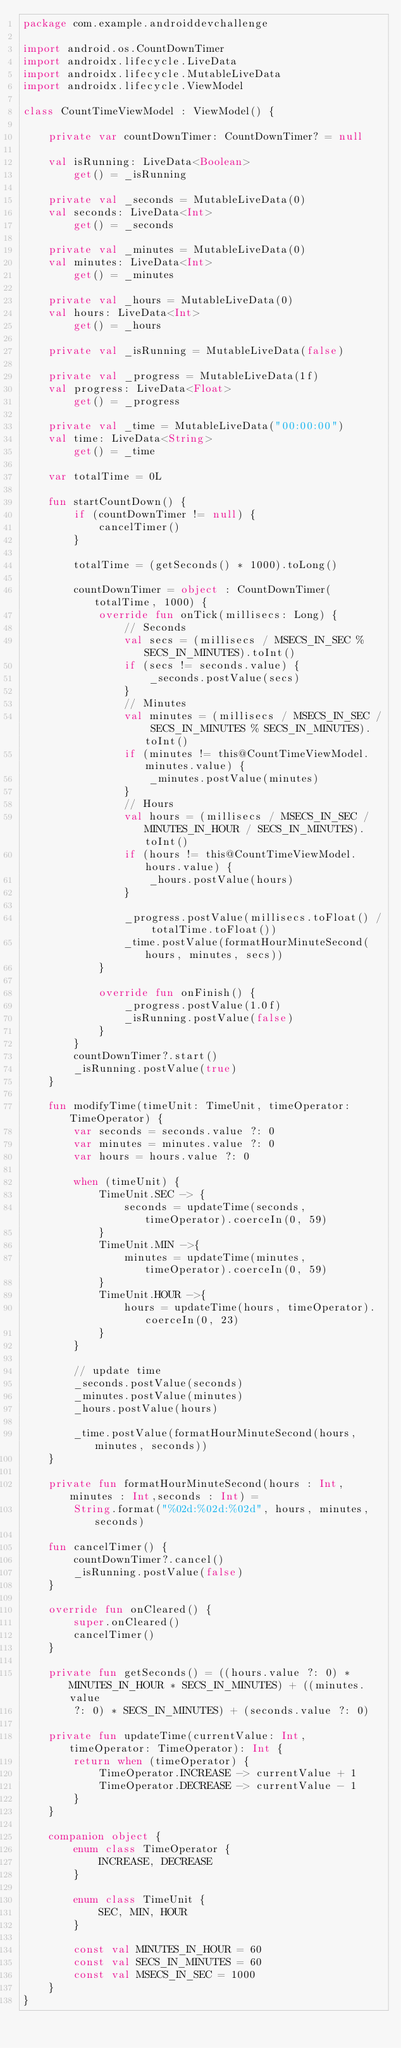Convert code to text. <code><loc_0><loc_0><loc_500><loc_500><_Kotlin_>package com.example.androiddevchallenge

import android.os.CountDownTimer
import androidx.lifecycle.LiveData
import androidx.lifecycle.MutableLiveData
import androidx.lifecycle.ViewModel

class CountTimeViewModel : ViewModel() {

    private var countDownTimer: CountDownTimer? = null

    val isRunning: LiveData<Boolean>
        get() = _isRunning

    private val _seconds = MutableLiveData(0)
    val seconds: LiveData<Int>
        get() = _seconds

    private val _minutes = MutableLiveData(0)
    val minutes: LiveData<Int>
        get() = _minutes

    private val _hours = MutableLiveData(0)
    val hours: LiveData<Int>
        get() = _hours

    private val _isRunning = MutableLiveData(false)

    private val _progress = MutableLiveData(1f)
    val progress: LiveData<Float>
        get() = _progress

    private val _time = MutableLiveData("00:00:00")
    val time: LiveData<String>
        get() = _time

    var totalTime = 0L

    fun startCountDown() {
        if (countDownTimer != null) {
            cancelTimer()
        }

        totalTime = (getSeconds() * 1000).toLong()

        countDownTimer = object : CountDownTimer(totalTime, 1000) {
            override fun onTick(millisecs: Long) {
                // Seconds
                val secs = (millisecs / MSECS_IN_SEC % SECS_IN_MINUTES).toInt()
                if (secs != seconds.value) {
                    _seconds.postValue(secs)
                }
                // Minutes
                val minutes = (millisecs / MSECS_IN_SEC / SECS_IN_MINUTES % SECS_IN_MINUTES).toInt()
                if (minutes != this@CountTimeViewModel.minutes.value) {
                    _minutes.postValue(minutes)
                }
                // Hours
                val hours = (millisecs / MSECS_IN_SEC / MINUTES_IN_HOUR / SECS_IN_MINUTES).toInt()
                if (hours != this@CountTimeViewModel.hours.value) {
                    _hours.postValue(hours)
                }

                _progress.postValue(millisecs.toFloat() / totalTime.toFloat())
                _time.postValue(formatHourMinuteSecond(hours, minutes, secs))
            }

            override fun onFinish() {
                _progress.postValue(1.0f)
                _isRunning.postValue(false)
            }
        }
        countDownTimer?.start()
        _isRunning.postValue(true)
    }

    fun modifyTime(timeUnit: TimeUnit, timeOperator: TimeOperator) {
        var seconds = seconds.value ?: 0
        var minutes = minutes.value ?: 0
        var hours = hours.value ?: 0

        when (timeUnit) {
            TimeUnit.SEC -> {
                seconds = updateTime(seconds, timeOperator).coerceIn(0, 59)
            }
            TimeUnit.MIN ->{
                minutes = updateTime(minutes, timeOperator).coerceIn(0, 59)
            }
            TimeUnit.HOUR ->{
                hours = updateTime(hours, timeOperator).coerceIn(0, 23)
            }
        }

        // update time
        _seconds.postValue(seconds)
        _minutes.postValue(minutes)
        _hours.postValue(hours)

        _time.postValue(formatHourMinuteSecond(hours, minutes, seconds))
    }

    private fun formatHourMinuteSecond(hours : Int,minutes : Int,seconds : Int) =
        String.format("%02d:%02d:%02d", hours, minutes, seconds)

    fun cancelTimer() {
        countDownTimer?.cancel()
        _isRunning.postValue(false)
    }

    override fun onCleared() {
        super.onCleared()
        cancelTimer()
    }

    private fun getSeconds() = ((hours.value ?: 0) * MINUTES_IN_HOUR * SECS_IN_MINUTES) + ((minutes.value
        ?: 0) * SECS_IN_MINUTES) + (seconds.value ?: 0)

    private fun updateTime(currentValue: Int, timeOperator: TimeOperator): Int {
        return when (timeOperator) {
            TimeOperator.INCREASE -> currentValue + 1
            TimeOperator.DECREASE -> currentValue - 1
        }
    }

    companion object {
        enum class TimeOperator {
            INCREASE, DECREASE
        }

        enum class TimeUnit {
            SEC, MIN, HOUR
        }

        const val MINUTES_IN_HOUR = 60
        const val SECS_IN_MINUTES = 60
        const val MSECS_IN_SEC = 1000
    }
}</code> 